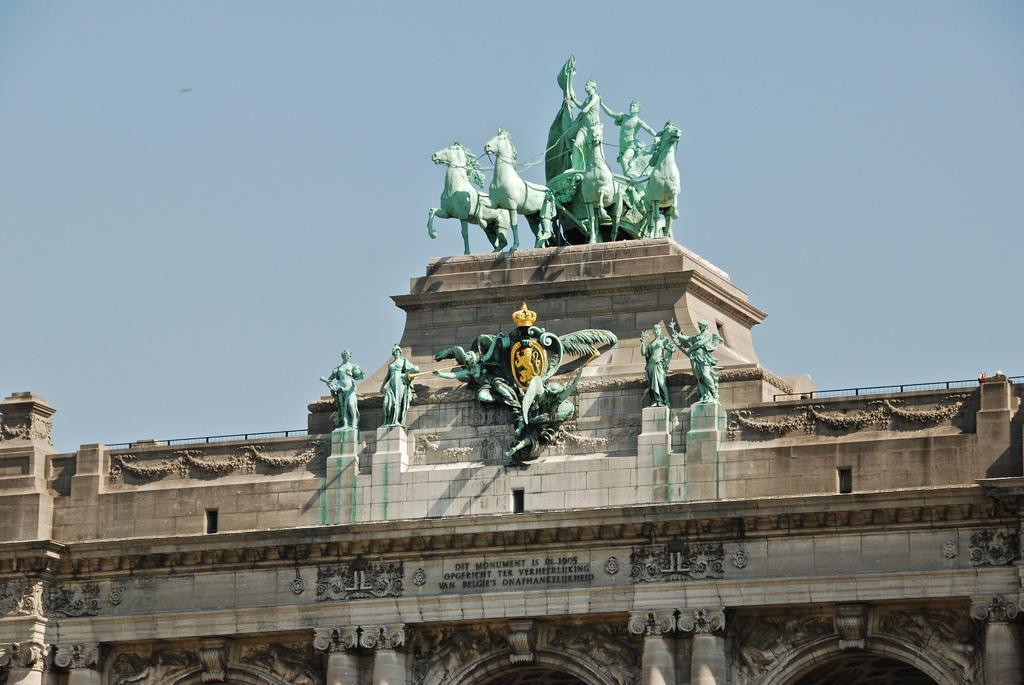Could you give a brief overview of what you see in this image? In this image I can see a building which is cream, brown and black in color. I can see few statues of persons, animals and a person sitting on the animal cart. In the background I can see the sky. 